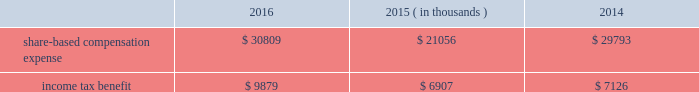2000 non-employee director stock option plan ( the 201cdirector stock option plan 201d ) , and the global payments inc .
2011 incentive plan ( the 201c2011 plan 201d ) ( collectively , the 201cplans 201d ) .
We made no further grants under the 2000 plan after the 2005 plan was effective , and the director stock option plan expired by its terms on february 1 , 2011 .
We will make no future grants under the 2000 plan , the 2005 plan or the director stock option plan .
The 2011 plan permits grants of equity to employees , officers , directors and consultants .
A total of 14.0 million shares of our common stock was reserved and made available for issuance pursuant to awards granted under the 2011 plan .
The table summarizes share-based compensation expense and the related income tax benefit recognized for our share-based awards and stock options ( in thousands ) : 2016 2015 2014 ( in thousands ) .
We grant various share-based awards pursuant to the plans under what we refer to as our 201clong-term incentive plan . 201d the awards are held in escrow and released upon the grantee 2019s satisfaction of conditions of the award certificate .
Restricted stock restricted stock awards vest over a period of time , provided , however , that if the grantee is not employed by us on the vesting date , the shares are forfeited .
Restricted shares cannot be sold or transferred until they have vested .
Restricted stock granted before fiscal 2015 vests in equal installments on each of the first four anniversaries of the grant date .
Restricted stock granted during fiscal 2015 and thereafter either vest in equal installments on each of the first three anniversaries of the grant date or cliff vest at the end of a three-year service period .
The grant date fair value of restricted stock , which is based on the quoted market value of our common stock at the closing of the award date , is recognized as share-based compensation expense on a straight-line basis over the vesting period .
Performance units certain of our executives have been granted performance units under our long-term incentive plan .
Performance units are performance-based restricted stock units that , after a performance period , convert into common shares , which may be restricted .
The number of shares is dependent upon the achievement of certain performance measures during the performance period .
The target number of performance units and any market-based performance measures ( 201cat threshold , 201d 201ctarget , 201d and 201cmaximum 201d ) are set by the compensation committee of our board of directors .
Performance units are converted only after the compensation committee certifies performance based on pre-established goals .
The performance units granted to certain executives in fiscal 2014 were based on a one-year performance period .
After the compensation committee certified the performance results , 25% ( 25 % ) of the performance units converted to unrestricted shares .
The remaining 75% ( 75 % ) converted to restricted shares that vest in equal installments on each of the first three anniversaries of the conversion date .
The performance units granted to certain executives during fiscal 2015 and fiscal 2016 were based on a three-year performance period .
After the compensation committee certifies the performance results for the three-year period , performance units earned will convert into unrestricted common stock .
The compensation committee may set a range of possible performance-based outcomes for performance units .
Depending on the achievement of the performance measures , the grantee may earn up to 200% ( 200 % ) of the target number of shares .
For awards with only performance conditions , we recognize compensation expense on a straight-line basis over the performance period using the grant date fair value of the award , which is based on the number of shares expected to be earned according to the level of achievement of performance goals .
If the number of shares expected to be earned were to change at any time during the performance period , we would make a cumulative adjustment to share-based compensation expense based on the revised number of shares expected to be earned .
Global payments inc .
| 2016 form 10-k annual report 2013 83 .
What is the estimated effective tax rate applied for share-based compensation expense in 2016? 
Computations: (9879 / 30809)
Answer: 0.32065. 